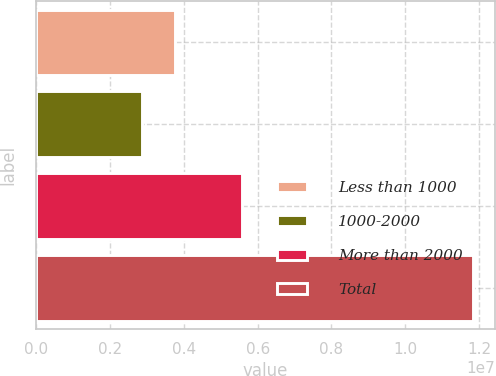Convert chart to OTSL. <chart><loc_0><loc_0><loc_500><loc_500><bar_chart><fcel>Less than 1000<fcel>1000-2000<fcel>More than 2000<fcel>Total<nl><fcel>3.76875e+06<fcel>2.87216e+06<fcel>5.57658e+06<fcel>1.1838e+07<nl></chart> 